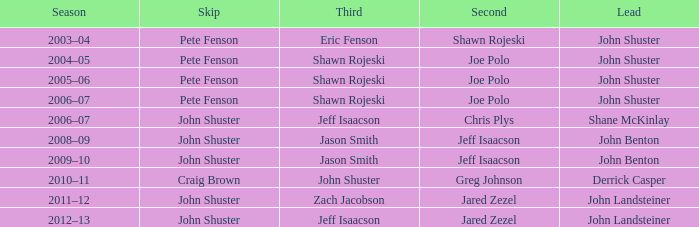In the 2005-06 season, who was the lead when pete fenson served as skip and joe polo played second? John Shuster. 